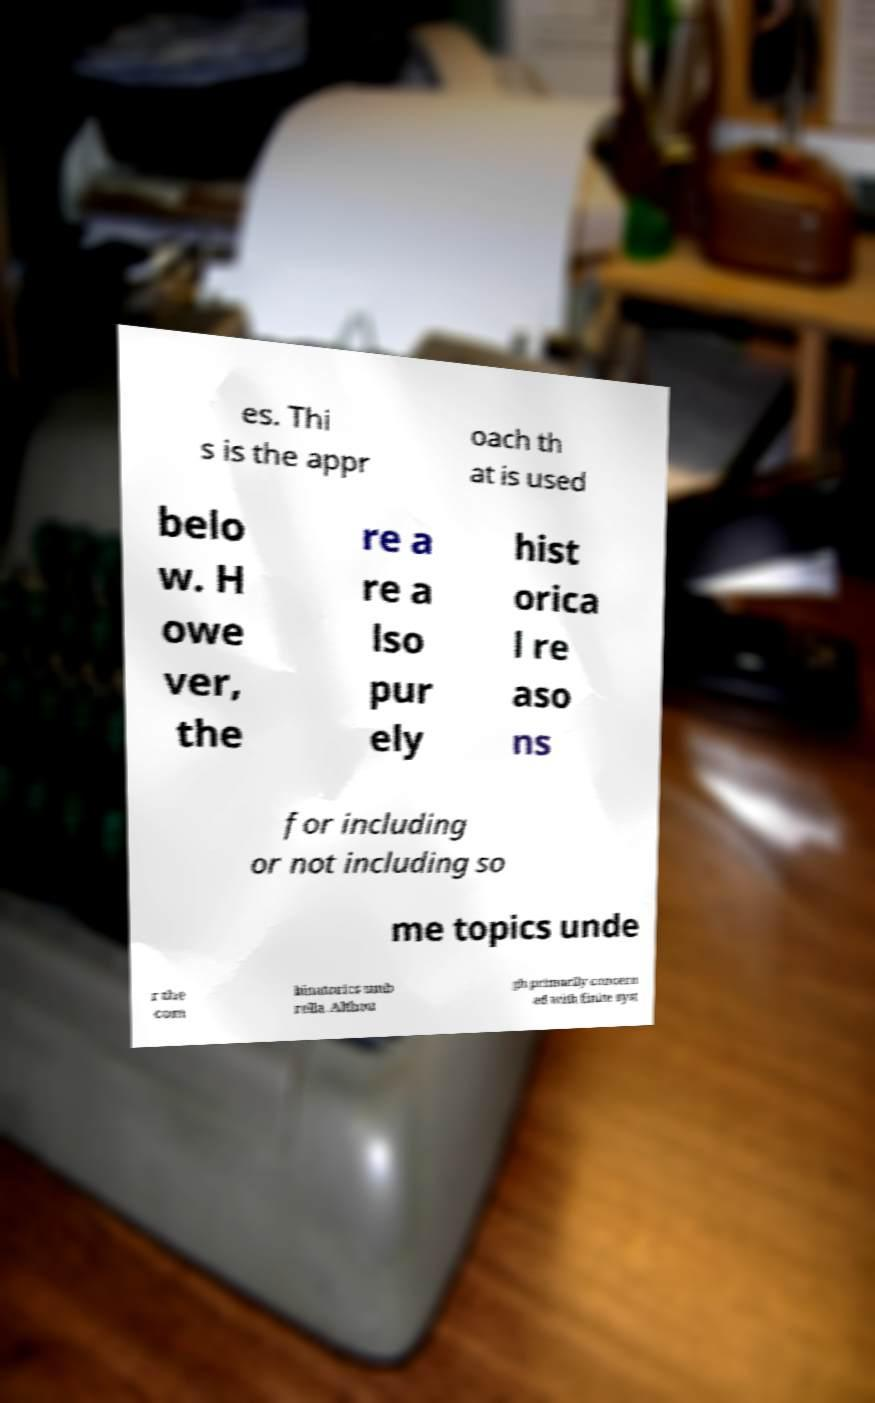Could you assist in decoding the text presented in this image and type it out clearly? es. Thi s is the appr oach th at is used belo w. H owe ver, the re a re a lso pur ely hist orica l re aso ns for including or not including so me topics unde r the com binatorics umb rella. Althou gh primarily concern ed with finite syst 